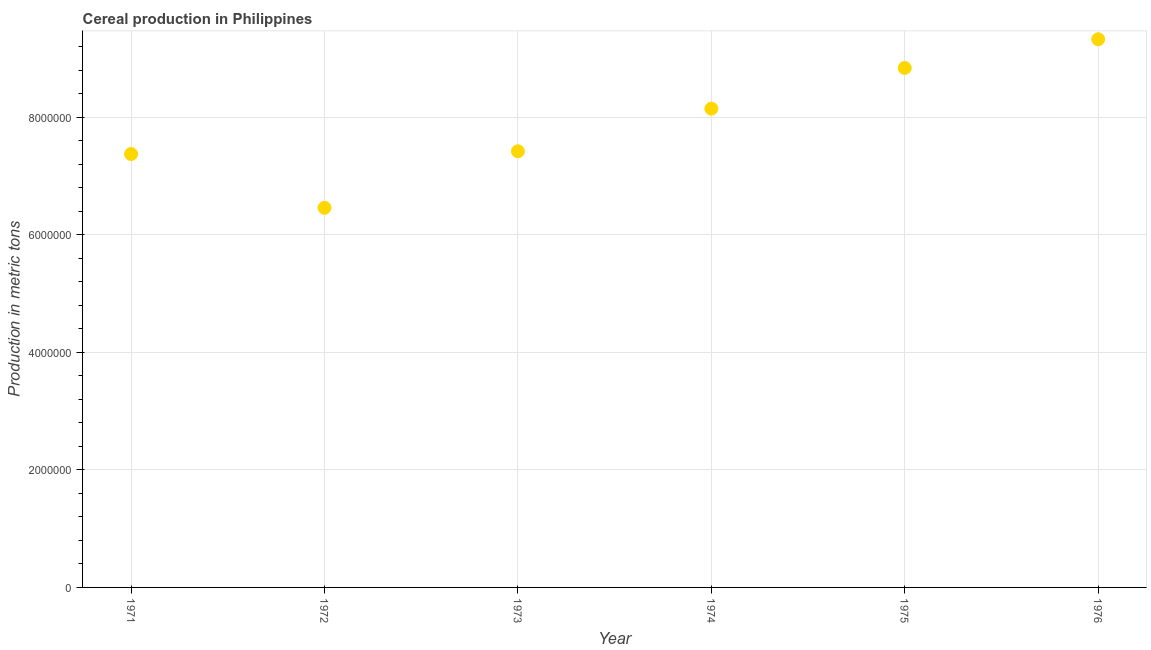What is the cereal production in 1974?
Your answer should be compact. 8.15e+06. Across all years, what is the maximum cereal production?
Give a very brief answer. 9.33e+06. Across all years, what is the minimum cereal production?
Your answer should be very brief. 6.46e+06. In which year was the cereal production maximum?
Make the answer very short. 1976. In which year was the cereal production minimum?
Offer a very short reply. 1972. What is the sum of the cereal production?
Offer a terse response. 4.76e+07. What is the difference between the cereal production in 1974 and 1976?
Offer a very short reply. -1.18e+06. What is the average cereal production per year?
Offer a terse response. 7.93e+06. What is the median cereal production?
Provide a short and direct response. 7.78e+06. In how many years, is the cereal production greater than 5200000 metric tons?
Make the answer very short. 6. What is the ratio of the cereal production in 1971 to that in 1976?
Offer a terse response. 0.79. What is the difference between the highest and the second highest cereal production?
Keep it short and to the point. 4.88e+05. Is the sum of the cereal production in 1971 and 1976 greater than the maximum cereal production across all years?
Provide a short and direct response. Yes. What is the difference between the highest and the lowest cereal production?
Your response must be concise. 2.87e+06. What is the difference between two consecutive major ticks on the Y-axis?
Your answer should be compact. 2.00e+06. Are the values on the major ticks of Y-axis written in scientific E-notation?
Your response must be concise. No. What is the title of the graph?
Make the answer very short. Cereal production in Philippines. What is the label or title of the Y-axis?
Give a very brief answer. Production in metric tons. What is the Production in metric tons in 1971?
Your answer should be very brief. 7.37e+06. What is the Production in metric tons in 1972?
Offer a very short reply. 6.46e+06. What is the Production in metric tons in 1973?
Give a very brief answer. 7.42e+06. What is the Production in metric tons in 1974?
Make the answer very short. 8.15e+06. What is the Production in metric tons in 1975?
Give a very brief answer. 8.84e+06. What is the Production in metric tons in 1976?
Your answer should be very brief. 9.33e+06. What is the difference between the Production in metric tons in 1971 and 1972?
Ensure brevity in your answer.  9.16e+05. What is the difference between the Production in metric tons in 1971 and 1973?
Keep it short and to the point. -4.65e+04. What is the difference between the Production in metric tons in 1971 and 1974?
Offer a very short reply. -7.72e+05. What is the difference between the Production in metric tons in 1971 and 1975?
Offer a very short reply. -1.46e+06. What is the difference between the Production in metric tons in 1971 and 1976?
Provide a succinct answer. -1.95e+06. What is the difference between the Production in metric tons in 1972 and 1973?
Offer a very short reply. -9.62e+05. What is the difference between the Production in metric tons in 1972 and 1974?
Provide a succinct answer. -1.69e+06. What is the difference between the Production in metric tons in 1972 and 1975?
Provide a short and direct response. -2.38e+06. What is the difference between the Production in metric tons in 1972 and 1976?
Your answer should be compact. -2.87e+06. What is the difference between the Production in metric tons in 1973 and 1974?
Keep it short and to the point. -7.25e+05. What is the difference between the Production in metric tons in 1973 and 1975?
Keep it short and to the point. -1.42e+06. What is the difference between the Production in metric tons in 1973 and 1976?
Your response must be concise. -1.91e+06. What is the difference between the Production in metric tons in 1974 and 1975?
Offer a terse response. -6.93e+05. What is the difference between the Production in metric tons in 1974 and 1976?
Keep it short and to the point. -1.18e+06. What is the difference between the Production in metric tons in 1975 and 1976?
Provide a short and direct response. -4.88e+05. What is the ratio of the Production in metric tons in 1971 to that in 1972?
Your response must be concise. 1.14. What is the ratio of the Production in metric tons in 1971 to that in 1973?
Provide a succinct answer. 0.99. What is the ratio of the Production in metric tons in 1971 to that in 1974?
Ensure brevity in your answer.  0.91. What is the ratio of the Production in metric tons in 1971 to that in 1975?
Keep it short and to the point. 0.83. What is the ratio of the Production in metric tons in 1971 to that in 1976?
Offer a terse response. 0.79. What is the ratio of the Production in metric tons in 1972 to that in 1973?
Your answer should be very brief. 0.87. What is the ratio of the Production in metric tons in 1972 to that in 1974?
Ensure brevity in your answer.  0.79. What is the ratio of the Production in metric tons in 1972 to that in 1975?
Give a very brief answer. 0.73. What is the ratio of the Production in metric tons in 1972 to that in 1976?
Provide a short and direct response. 0.69. What is the ratio of the Production in metric tons in 1973 to that in 1974?
Give a very brief answer. 0.91. What is the ratio of the Production in metric tons in 1973 to that in 1975?
Make the answer very short. 0.84. What is the ratio of the Production in metric tons in 1973 to that in 1976?
Your answer should be compact. 0.8. What is the ratio of the Production in metric tons in 1974 to that in 1975?
Make the answer very short. 0.92. What is the ratio of the Production in metric tons in 1974 to that in 1976?
Your answer should be very brief. 0.87. What is the ratio of the Production in metric tons in 1975 to that in 1976?
Ensure brevity in your answer.  0.95. 